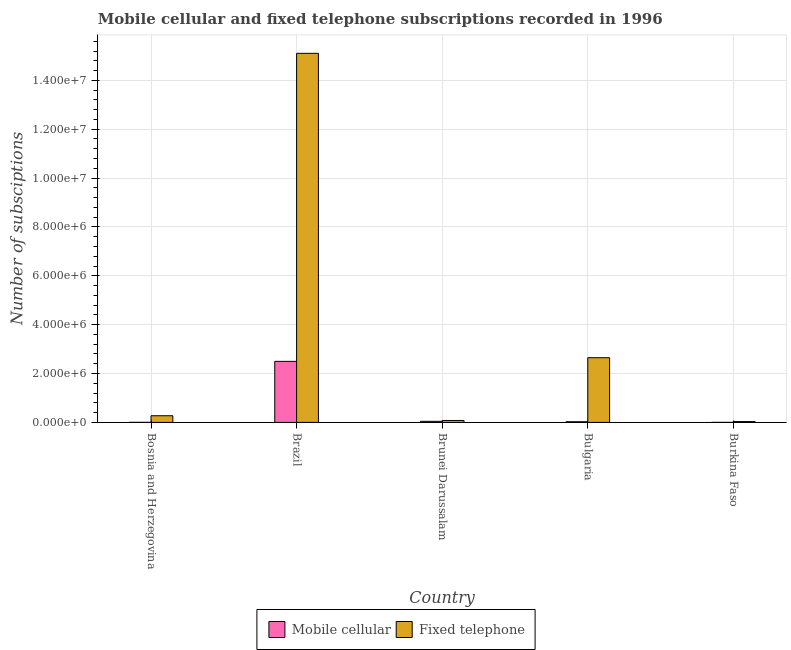How many groups of bars are there?
Your answer should be compact. 5. What is the number of fixed telephone subscriptions in Bulgaria?
Offer a very short reply. 2.65e+06. Across all countries, what is the maximum number of mobile cellular subscriptions?
Your answer should be compact. 2.50e+06. Across all countries, what is the minimum number of mobile cellular subscriptions?
Give a very brief answer. 525. In which country was the number of fixed telephone subscriptions minimum?
Your answer should be very brief. Burkina Faso. What is the total number of mobile cellular subscriptions in the graph?
Give a very brief answer. 2.57e+06. What is the difference between the number of fixed telephone subscriptions in Bosnia and Herzegovina and that in Brazil?
Your response must be concise. -1.48e+07. What is the difference between the number of fixed telephone subscriptions in Burkina Faso and the number of mobile cellular subscriptions in Bulgaria?
Make the answer very short. 7467. What is the average number of fixed telephone subscriptions per country?
Ensure brevity in your answer.  3.63e+06. What is the difference between the number of mobile cellular subscriptions and number of fixed telephone subscriptions in Brazil?
Provide a succinct answer. -1.26e+07. What is the ratio of the number of fixed telephone subscriptions in Brunei Darussalam to that in Bulgaria?
Provide a short and direct response. 0.03. Is the number of fixed telephone subscriptions in Brazil less than that in Bulgaria?
Your response must be concise. No. Is the difference between the number of fixed telephone subscriptions in Brazil and Brunei Darussalam greater than the difference between the number of mobile cellular subscriptions in Brazil and Brunei Darussalam?
Offer a very short reply. Yes. What is the difference between the highest and the second highest number of fixed telephone subscriptions?
Keep it short and to the point. 1.25e+07. What is the difference between the highest and the lowest number of fixed telephone subscriptions?
Ensure brevity in your answer.  1.51e+07. In how many countries, is the number of mobile cellular subscriptions greater than the average number of mobile cellular subscriptions taken over all countries?
Give a very brief answer. 1. What does the 2nd bar from the left in Brunei Darussalam represents?
Your answer should be compact. Fixed telephone. What does the 2nd bar from the right in Bulgaria represents?
Give a very brief answer. Mobile cellular. How many countries are there in the graph?
Provide a short and direct response. 5. What is the difference between two consecutive major ticks on the Y-axis?
Give a very brief answer. 2.00e+06. Are the values on the major ticks of Y-axis written in scientific E-notation?
Your answer should be compact. Yes. Does the graph contain any zero values?
Make the answer very short. No. Does the graph contain grids?
Ensure brevity in your answer.  Yes. What is the title of the graph?
Offer a very short reply. Mobile cellular and fixed telephone subscriptions recorded in 1996. Does "Excluding technical cooperation" appear as one of the legend labels in the graph?
Provide a short and direct response. No. What is the label or title of the Y-axis?
Keep it short and to the point. Number of subsciptions. What is the Number of subsciptions of Mobile cellular in Bosnia and Herzegovina?
Provide a short and direct response. 1500. What is the Number of subsciptions in Fixed telephone in Bosnia and Herzegovina?
Offer a very short reply. 2.72e+05. What is the Number of subsciptions of Mobile cellular in Brazil?
Offer a very short reply. 2.50e+06. What is the Number of subsciptions of Fixed telephone in Brazil?
Your answer should be compact. 1.51e+07. What is the Number of subsciptions of Mobile cellular in Brunei Darussalam?
Keep it short and to the point. 4.35e+04. What is the Number of subsciptions of Fixed telephone in Brunei Darussalam?
Provide a succinct answer. 7.88e+04. What is the Number of subsciptions of Mobile cellular in Bulgaria?
Offer a very short reply. 2.66e+04. What is the Number of subsciptions in Fixed telephone in Bulgaria?
Give a very brief answer. 2.65e+06. What is the Number of subsciptions of Mobile cellular in Burkina Faso?
Ensure brevity in your answer.  525. What is the Number of subsciptions in Fixed telephone in Burkina Faso?
Your answer should be compact. 3.41e+04. Across all countries, what is the maximum Number of subsciptions in Mobile cellular?
Give a very brief answer. 2.50e+06. Across all countries, what is the maximum Number of subsciptions in Fixed telephone?
Offer a very short reply. 1.51e+07. Across all countries, what is the minimum Number of subsciptions of Mobile cellular?
Keep it short and to the point. 525. Across all countries, what is the minimum Number of subsciptions in Fixed telephone?
Provide a short and direct response. 3.41e+04. What is the total Number of subsciptions of Mobile cellular in the graph?
Make the answer very short. 2.57e+06. What is the total Number of subsciptions of Fixed telephone in the graph?
Provide a short and direct response. 1.81e+07. What is the difference between the Number of subsciptions in Mobile cellular in Bosnia and Herzegovina and that in Brazil?
Your answer should be compact. -2.50e+06. What is the difference between the Number of subsciptions in Fixed telephone in Bosnia and Herzegovina and that in Brazil?
Offer a terse response. -1.48e+07. What is the difference between the Number of subsciptions of Mobile cellular in Bosnia and Herzegovina and that in Brunei Darussalam?
Give a very brief answer. -4.20e+04. What is the difference between the Number of subsciptions in Fixed telephone in Bosnia and Herzegovina and that in Brunei Darussalam?
Ensure brevity in your answer.  1.93e+05. What is the difference between the Number of subsciptions in Mobile cellular in Bosnia and Herzegovina and that in Bulgaria?
Your response must be concise. -2.51e+04. What is the difference between the Number of subsciptions of Fixed telephone in Bosnia and Herzegovina and that in Bulgaria?
Your answer should be compact. -2.38e+06. What is the difference between the Number of subsciptions in Mobile cellular in Bosnia and Herzegovina and that in Burkina Faso?
Offer a terse response. 975. What is the difference between the Number of subsciptions of Fixed telephone in Bosnia and Herzegovina and that in Burkina Faso?
Offer a very short reply. 2.38e+05. What is the difference between the Number of subsciptions of Mobile cellular in Brazil and that in Brunei Darussalam?
Give a very brief answer. 2.45e+06. What is the difference between the Number of subsciptions in Fixed telephone in Brazil and that in Brunei Darussalam?
Provide a succinct answer. 1.50e+07. What is the difference between the Number of subsciptions of Mobile cellular in Brazil and that in Bulgaria?
Make the answer very short. 2.47e+06. What is the difference between the Number of subsciptions in Fixed telephone in Brazil and that in Bulgaria?
Give a very brief answer. 1.25e+07. What is the difference between the Number of subsciptions in Mobile cellular in Brazil and that in Burkina Faso?
Offer a very short reply. 2.50e+06. What is the difference between the Number of subsciptions in Fixed telephone in Brazil and that in Burkina Faso?
Offer a terse response. 1.51e+07. What is the difference between the Number of subsciptions in Mobile cellular in Brunei Darussalam and that in Bulgaria?
Ensure brevity in your answer.  1.69e+04. What is the difference between the Number of subsciptions of Fixed telephone in Brunei Darussalam and that in Bulgaria?
Your answer should be very brief. -2.57e+06. What is the difference between the Number of subsciptions of Mobile cellular in Brunei Darussalam and that in Burkina Faso?
Your answer should be very brief. 4.30e+04. What is the difference between the Number of subsciptions of Fixed telephone in Brunei Darussalam and that in Burkina Faso?
Offer a terse response. 4.47e+04. What is the difference between the Number of subsciptions of Mobile cellular in Bulgaria and that in Burkina Faso?
Your response must be concise. 2.61e+04. What is the difference between the Number of subsciptions of Fixed telephone in Bulgaria and that in Burkina Faso?
Offer a very short reply. 2.61e+06. What is the difference between the Number of subsciptions of Mobile cellular in Bosnia and Herzegovina and the Number of subsciptions of Fixed telephone in Brazil?
Your response must be concise. -1.51e+07. What is the difference between the Number of subsciptions of Mobile cellular in Bosnia and Herzegovina and the Number of subsciptions of Fixed telephone in Brunei Darussalam?
Provide a succinct answer. -7.73e+04. What is the difference between the Number of subsciptions in Mobile cellular in Bosnia and Herzegovina and the Number of subsciptions in Fixed telephone in Bulgaria?
Keep it short and to the point. -2.65e+06. What is the difference between the Number of subsciptions in Mobile cellular in Bosnia and Herzegovina and the Number of subsciptions in Fixed telephone in Burkina Faso?
Your answer should be very brief. -3.26e+04. What is the difference between the Number of subsciptions of Mobile cellular in Brazil and the Number of subsciptions of Fixed telephone in Brunei Darussalam?
Keep it short and to the point. 2.42e+06. What is the difference between the Number of subsciptions in Mobile cellular in Brazil and the Number of subsciptions in Fixed telephone in Bulgaria?
Make the answer very short. -1.49e+05. What is the difference between the Number of subsciptions in Mobile cellular in Brazil and the Number of subsciptions in Fixed telephone in Burkina Faso?
Ensure brevity in your answer.  2.46e+06. What is the difference between the Number of subsciptions of Mobile cellular in Brunei Darussalam and the Number of subsciptions of Fixed telephone in Bulgaria?
Keep it short and to the point. -2.60e+06. What is the difference between the Number of subsciptions in Mobile cellular in Brunei Darussalam and the Number of subsciptions in Fixed telephone in Burkina Faso?
Provide a succinct answer. 9469. What is the difference between the Number of subsciptions in Mobile cellular in Bulgaria and the Number of subsciptions in Fixed telephone in Burkina Faso?
Offer a terse response. -7467. What is the average Number of subsciptions in Mobile cellular per country?
Give a very brief answer. 5.14e+05. What is the average Number of subsciptions of Fixed telephone per country?
Your answer should be compact. 3.63e+06. What is the difference between the Number of subsciptions in Mobile cellular and Number of subsciptions in Fixed telephone in Bosnia and Herzegovina?
Make the answer very short. -2.71e+05. What is the difference between the Number of subsciptions of Mobile cellular and Number of subsciptions of Fixed telephone in Brazil?
Make the answer very short. -1.26e+07. What is the difference between the Number of subsciptions in Mobile cellular and Number of subsciptions in Fixed telephone in Brunei Darussalam?
Ensure brevity in your answer.  -3.53e+04. What is the difference between the Number of subsciptions of Mobile cellular and Number of subsciptions of Fixed telephone in Bulgaria?
Your response must be concise. -2.62e+06. What is the difference between the Number of subsciptions in Mobile cellular and Number of subsciptions in Fixed telephone in Burkina Faso?
Ensure brevity in your answer.  -3.35e+04. What is the ratio of the Number of subsciptions of Mobile cellular in Bosnia and Herzegovina to that in Brazil?
Keep it short and to the point. 0. What is the ratio of the Number of subsciptions of Fixed telephone in Bosnia and Herzegovina to that in Brazil?
Keep it short and to the point. 0.02. What is the ratio of the Number of subsciptions of Mobile cellular in Bosnia and Herzegovina to that in Brunei Darussalam?
Offer a terse response. 0.03. What is the ratio of the Number of subsciptions of Fixed telephone in Bosnia and Herzegovina to that in Brunei Darussalam?
Ensure brevity in your answer.  3.46. What is the ratio of the Number of subsciptions of Mobile cellular in Bosnia and Herzegovina to that in Bulgaria?
Offer a terse response. 0.06. What is the ratio of the Number of subsciptions in Fixed telephone in Bosnia and Herzegovina to that in Bulgaria?
Your answer should be compact. 0.1. What is the ratio of the Number of subsciptions in Mobile cellular in Bosnia and Herzegovina to that in Burkina Faso?
Keep it short and to the point. 2.86. What is the ratio of the Number of subsciptions in Fixed telephone in Bosnia and Herzegovina to that in Burkina Faso?
Provide a succinct answer. 7.99. What is the ratio of the Number of subsciptions of Mobile cellular in Brazil to that in Brunei Darussalam?
Offer a very short reply. 57.4. What is the ratio of the Number of subsciptions in Fixed telephone in Brazil to that in Brunei Darussalam?
Your answer should be compact. 191.71. What is the ratio of the Number of subsciptions in Mobile cellular in Brazil to that in Bulgaria?
Offer a terse response. 93.96. What is the ratio of the Number of subsciptions in Fixed telephone in Brazil to that in Bulgaria?
Keep it short and to the point. 5.71. What is the ratio of the Number of subsciptions in Mobile cellular in Brazil to that in Burkina Faso?
Offer a terse response. 4758.39. What is the ratio of the Number of subsciptions in Fixed telephone in Brazil to that in Burkina Faso?
Your answer should be compact. 443.57. What is the ratio of the Number of subsciptions of Mobile cellular in Brunei Darussalam to that in Bulgaria?
Offer a very short reply. 1.64. What is the ratio of the Number of subsciptions of Fixed telephone in Brunei Darussalam to that in Bulgaria?
Make the answer very short. 0.03. What is the ratio of the Number of subsciptions in Mobile cellular in Brunei Darussalam to that in Burkina Faso?
Ensure brevity in your answer.  82.9. What is the ratio of the Number of subsciptions in Fixed telephone in Brunei Darussalam to that in Burkina Faso?
Keep it short and to the point. 2.31. What is the ratio of the Number of subsciptions in Mobile cellular in Bulgaria to that in Burkina Faso?
Ensure brevity in your answer.  50.64. What is the ratio of the Number of subsciptions in Fixed telephone in Bulgaria to that in Burkina Faso?
Ensure brevity in your answer.  77.74. What is the difference between the highest and the second highest Number of subsciptions in Mobile cellular?
Your response must be concise. 2.45e+06. What is the difference between the highest and the second highest Number of subsciptions of Fixed telephone?
Offer a terse response. 1.25e+07. What is the difference between the highest and the lowest Number of subsciptions in Mobile cellular?
Offer a very short reply. 2.50e+06. What is the difference between the highest and the lowest Number of subsciptions in Fixed telephone?
Ensure brevity in your answer.  1.51e+07. 